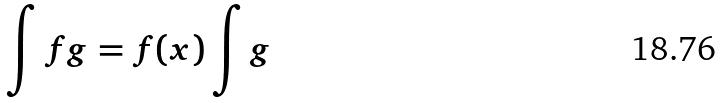Convert formula to latex. <formula><loc_0><loc_0><loc_500><loc_500>\int f g = f ( x ) \int g</formula> 